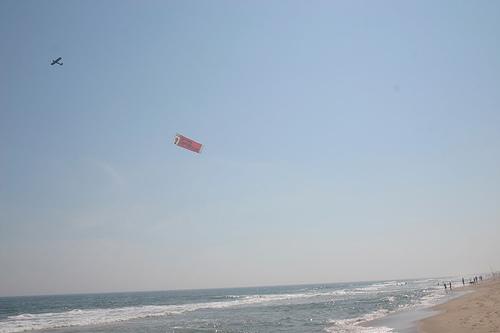Where are the people?
Short answer required. Beach. How rough are the waves?
Short answer required. Calm. Are there huge waves?
Concise answer only. No. Is the shore rocky?
Keep it brief. No. Is the man about to surf a wave?
Concise answer only. No. What is in the background of the picture?
Give a very brief answer. Plane. What color is the small plane?
Quick response, please. Black. Is this a rocky shore?
Answer briefly. No. Are they riding a wave?
Answer briefly. No. Is there an airplane?
Answer briefly. Yes. What is this person doing?
Quick response, please. Flying kite. Are there a lot of waves?
Keep it brief. Yes. What is the weather like?
Write a very short answer. Sunny. Is it a sunny day outside?
Keep it brief. Yes. 